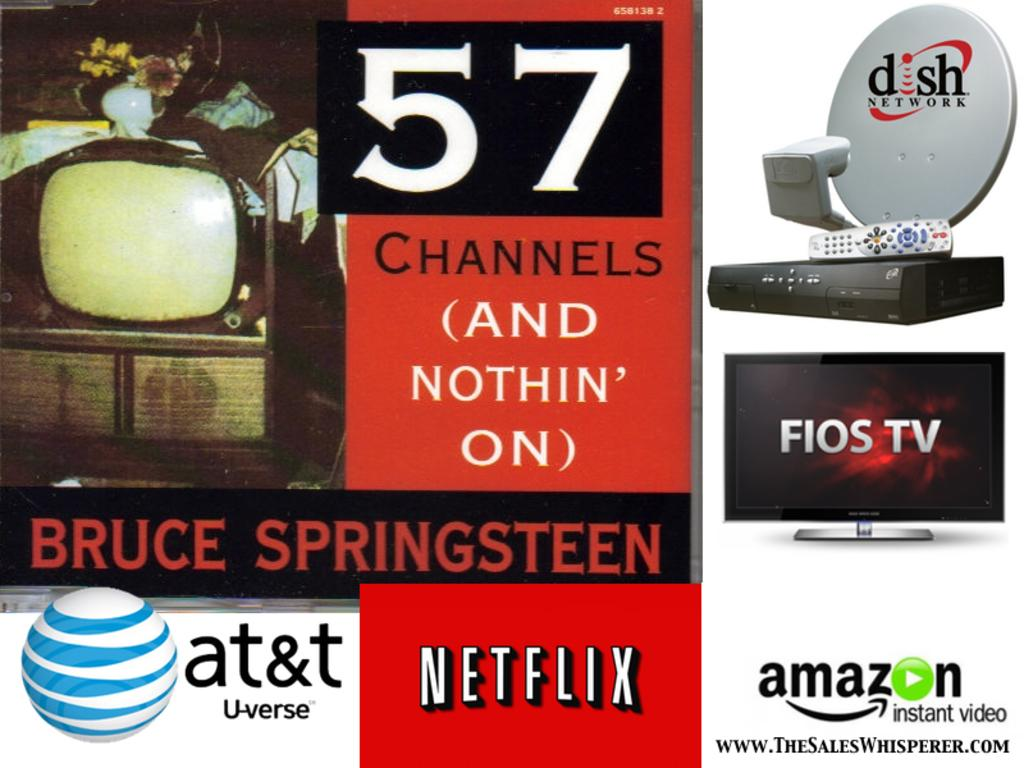<image>
Create a compact narrative representing the image presented. Several different television providers such as at&t, Netflix, and Amazon are displayed on an advertisement. 